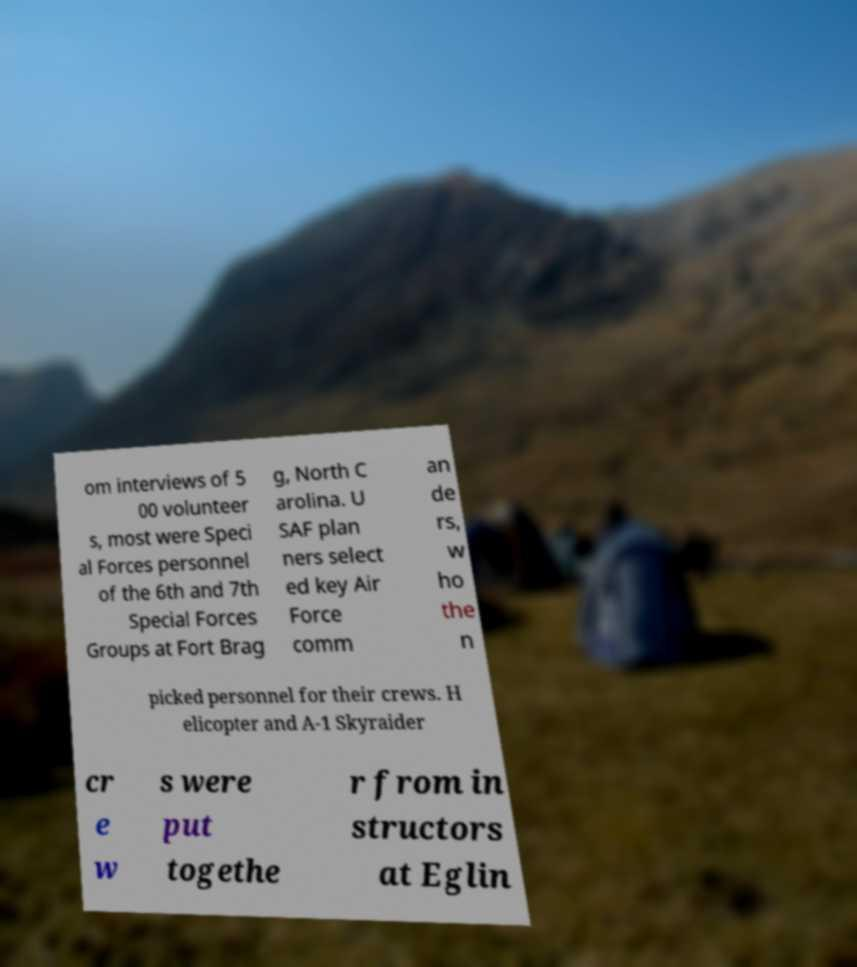Can you accurately transcribe the text from the provided image for me? om interviews of 5 00 volunteer s, most were Speci al Forces personnel of the 6th and 7th Special Forces Groups at Fort Brag g, North C arolina. U SAF plan ners select ed key Air Force comm an de rs, w ho the n picked personnel for their crews. H elicopter and A-1 Skyraider cr e w s were put togethe r from in structors at Eglin 